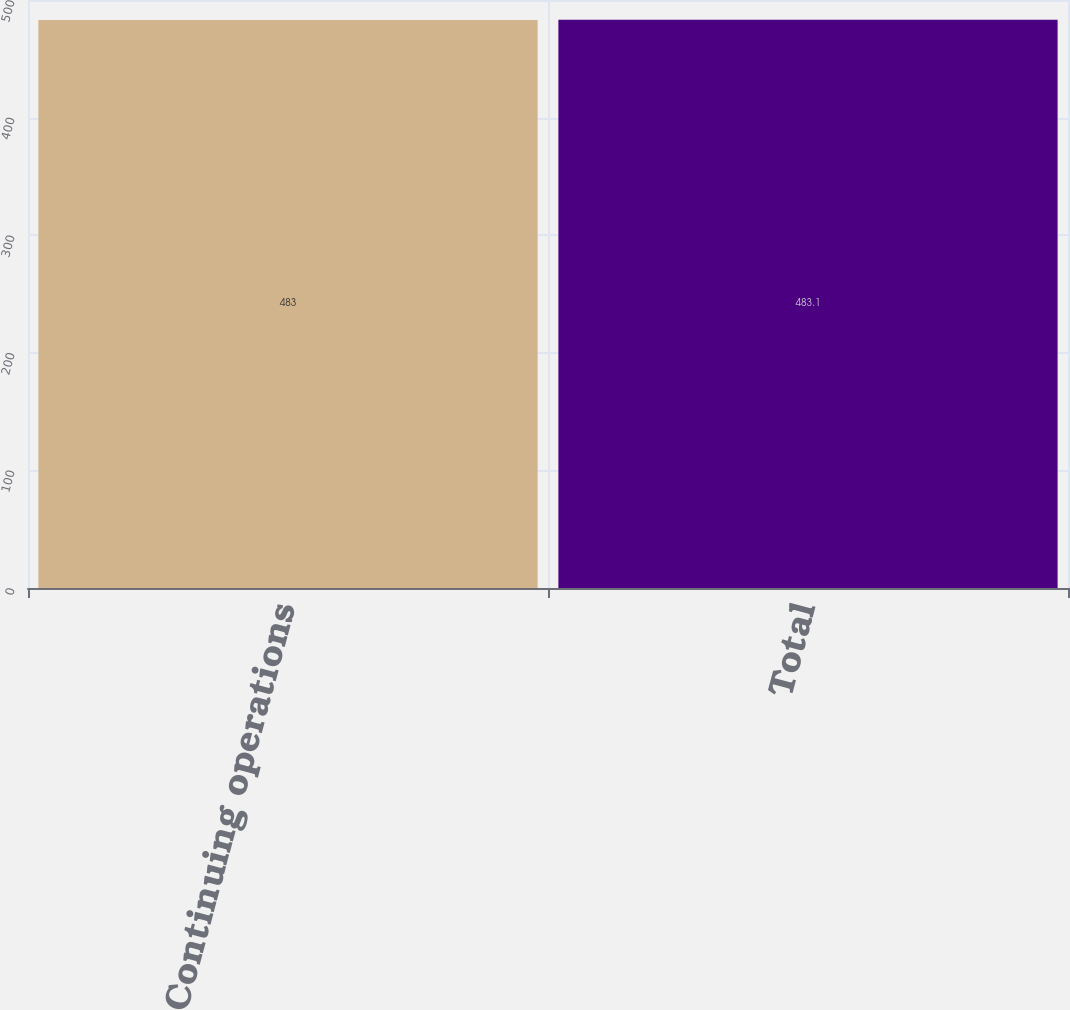<chart> <loc_0><loc_0><loc_500><loc_500><bar_chart><fcel>Continuing operations<fcel>Total<nl><fcel>483<fcel>483.1<nl></chart> 